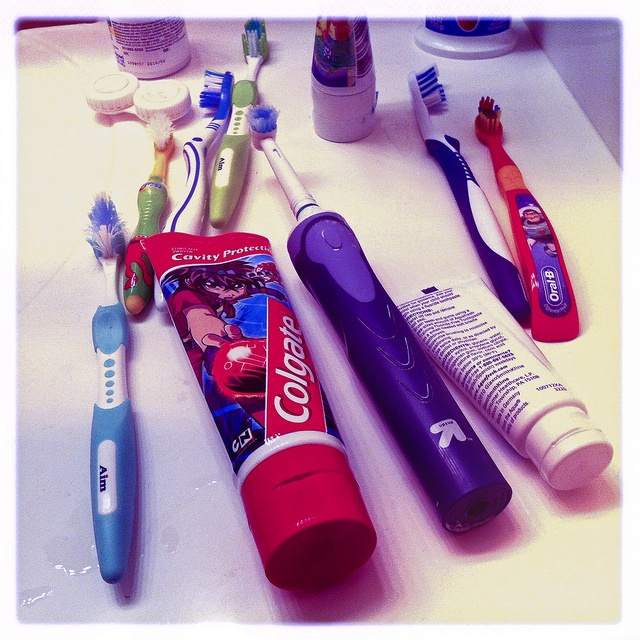Describe the objects in this image and their specific colors. I can see toothbrush in white, navy, and purple tones, toothbrush in white, lightgray, blue, gray, and darkgray tones, toothbrush in white, brown, and purple tones, toothbrush in white, navy, lightgray, and purple tones, and toothbrush in white, tan, beige, gray, and darkgray tones in this image. 